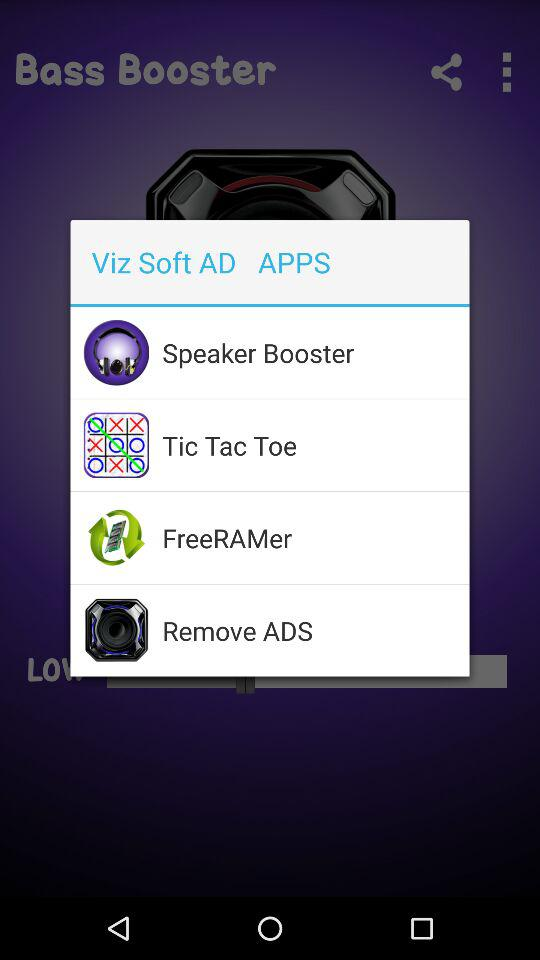What apps are available? The available apps are "Bass Booster", "Speaker Booster", "Tic Tac Toe", "FreeRAMer" and "Remove ADS". 